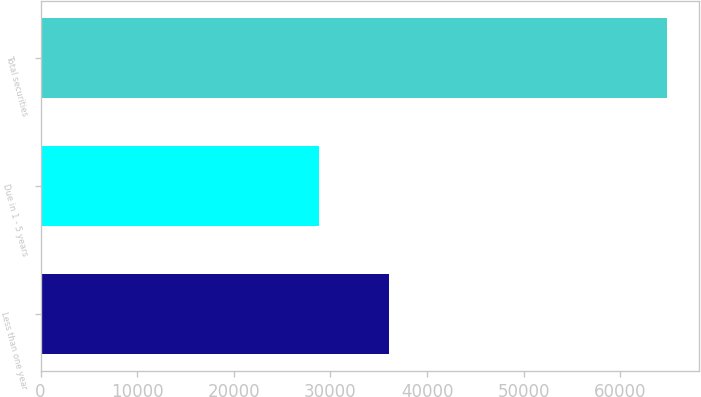Convert chart. <chart><loc_0><loc_0><loc_500><loc_500><bar_chart><fcel>Less than one year<fcel>Due in 1 - 5 years<fcel>Total securities<nl><fcel>36062<fcel>28801<fcel>64863<nl></chart> 